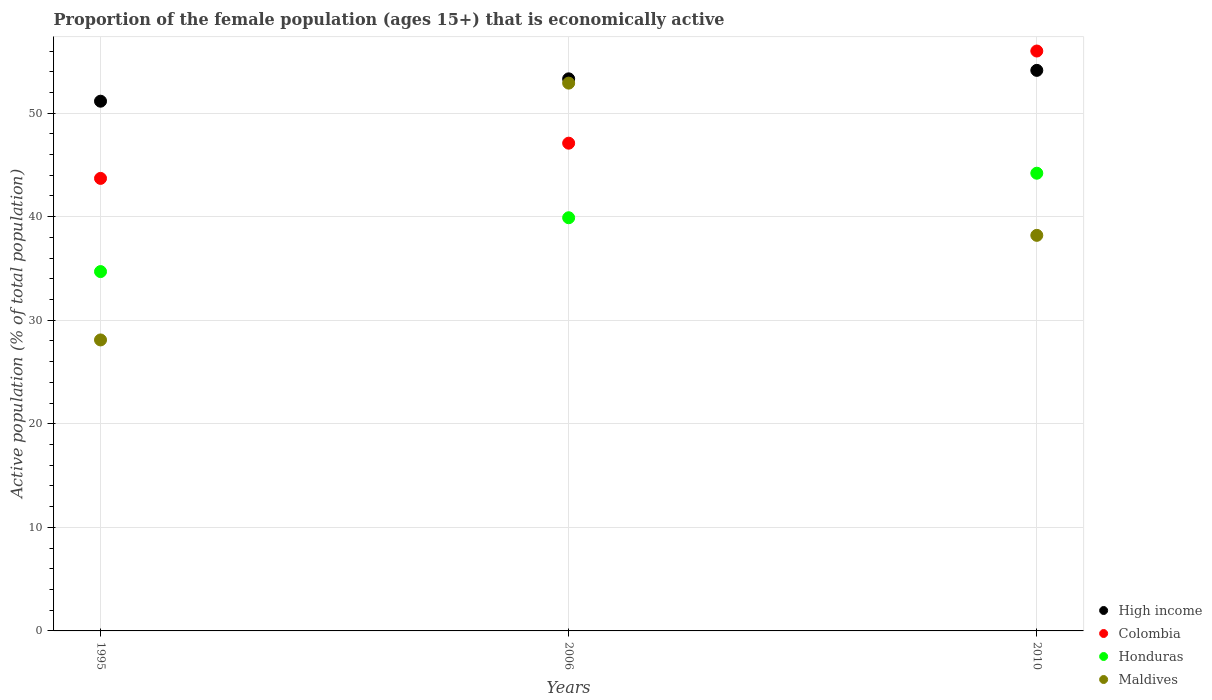What is the proportion of the female population that is economically active in Maldives in 2010?
Make the answer very short. 38.2. Across all years, what is the maximum proportion of the female population that is economically active in Maldives?
Your answer should be very brief. 52.9. Across all years, what is the minimum proportion of the female population that is economically active in High income?
Give a very brief answer. 51.15. In which year was the proportion of the female population that is economically active in Maldives minimum?
Offer a terse response. 1995. What is the total proportion of the female population that is economically active in High income in the graph?
Your answer should be very brief. 158.6. What is the difference between the proportion of the female population that is economically active in Maldives in 2006 and that in 2010?
Offer a terse response. 14.7. What is the difference between the proportion of the female population that is economically active in Colombia in 2006 and the proportion of the female population that is economically active in Maldives in 1995?
Provide a short and direct response. 19. What is the average proportion of the female population that is economically active in High income per year?
Give a very brief answer. 52.87. In the year 2006, what is the difference between the proportion of the female population that is economically active in Colombia and proportion of the female population that is economically active in Maldives?
Your response must be concise. -5.8. What is the ratio of the proportion of the female population that is economically active in Honduras in 2006 to that in 2010?
Ensure brevity in your answer.  0.9. Is the difference between the proportion of the female population that is economically active in Colombia in 1995 and 2006 greater than the difference between the proportion of the female population that is economically active in Maldives in 1995 and 2006?
Your answer should be very brief. Yes. What is the difference between the highest and the second highest proportion of the female population that is economically active in High income?
Your response must be concise. 0.82. What is the difference between the highest and the lowest proportion of the female population that is economically active in Maldives?
Provide a short and direct response. 24.8. Does the proportion of the female population that is economically active in Colombia monotonically increase over the years?
Your answer should be very brief. Yes. Is the proportion of the female population that is economically active in Honduras strictly greater than the proportion of the female population that is economically active in Maldives over the years?
Give a very brief answer. No. How many years are there in the graph?
Keep it short and to the point. 3. Where does the legend appear in the graph?
Your answer should be compact. Bottom right. How many legend labels are there?
Make the answer very short. 4. How are the legend labels stacked?
Keep it short and to the point. Vertical. What is the title of the graph?
Offer a very short reply. Proportion of the female population (ages 15+) that is economically active. Does "Guyana" appear as one of the legend labels in the graph?
Offer a very short reply. No. What is the label or title of the Y-axis?
Your response must be concise. Active population (% of total population). What is the Active population (% of total population) of High income in 1995?
Give a very brief answer. 51.15. What is the Active population (% of total population) in Colombia in 1995?
Make the answer very short. 43.7. What is the Active population (% of total population) of Honduras in 1995?
Provide a succinct answer. 34.7. What is the Active population (% of total population) of Maldives in 1995?
Your response must be concise. 28.1. What is the Active population (% of total population) in High income in 2006?
Ensure brevity in your answer.  53.31. What is the Active population (% of total population) in Colombia in 2006?
Provide a short and direct response. 47.1. What is the Active population (% of total population) in Honduras in 2006?
Offer a terse response. 39.9. What is the Active population (% of total population) in Maldives in 2006?
Your response must be concise. 52.9. What is the Active population (% of total population) of High income in 2010?
Ensure brevity in your answer.  54.13. What is the Active population (% of total population) in Honduras in 2010?
Your answer should be compact. 44.2. What is the Active population (% of total population) in Maldives in 2010?
Give a very brief answer. 38.2. Across all years, what is the maximum Active population (% of total population) in High income?
Offer a very short reply. 54.13. Across all years, what is the maximum Active population (% of total population) of Colombia?
Give a very brief answer. 56. Across all years, what is the maximum Active population (% of total population) in Honduras?
Keep it short and to the point. 44.2. Across all years, what is the maximum Active population (% of total population) of Maldives?
Offer a very short reply. 52.9. Across all years, what is the minimum Active population (% of total population) of High income?
Ensure brevity in your answer.  51.15. Across all years, what is the minimum Active population (% of total population) of Colombia?
Ensure brevity in your answer.  43.7. Across all years, what is the minimum Active population (% of total population) of Honduras?
Keep it short and to the point. 34.7. Across all years, what is the minimum Active population (% of total population) in Maldives?
Provide a succinct answer. 28.1. What is the total Active population (% of total population) in High income in the graph?
Ensure brevity in your answer.  158.6. What is the total Active population (% of total population) in Colombia in the graph?
Offer a terse response. 146.8. What is the total Active population (% of total population) in Honduras in the graph?
Your response must be concise. 118.8. What is the total Active population (% of total population) of Maldives in the graph?
Provide a short and direct response. 119.2. What is the difference between the Active population (% of total population) of High income in 1995 and that in 2006?
Your answer should be very brief. -2.16. What is the difference between the Active population (% of total population) in Colombia in 1995 and that in 2006?
Keep it short and to the point. -3.4. What is the difference between the Active population (% of total population) in Maldives in 1995 and that in 2006?
Make the answer very short. -24.8. What is the difference between the Active population (% of total population) in High income in 1995 and that in 2010?
Your answer should be compact. -2.98. What is the difference between the Active population (% of total population) in Colombia in 1995 and that in 2010?
Keep it short and to the point. -12.3. What is the difference between the Active population (% of total population) of Honduras in 1995 and that in 2010?
Offer a terse response. -9.5. What is the difference between the Active population (% of total population) in Maldives in 1995 and that in 2010?
Give a very brief answer. -10.1. What is the difference between the Active population (% of total population) of High income in 2006 and that in 2010?
Your answer should be compact. -0.82. What is the difference between the Active population (% of total population) in High income in 1995 and the Active population (% of total population) in Colombia in 2006?
Your response must be concise. 4.05. What is the difference between the Active population (% of total population) in High income in 1995 and the Active population (% of total population) in Honduras in 2006?
Your answer should be compact. 11.25. What is the difference between the Active population (% of total population) of High income in 1995 and the Active population (% of total population) of Maldives in 2006?
Ensure brevity in your answer.  -1.75. What is the difference between the Active population (% of total population) in Colombia in 1995 and the Active population (% of total population) in Maldives in 2006?
Offer a terse response. -9.2. What is the difference between the Active population (% of total population) in Honduras in 1995 and the Active population (% of total population) in Maldives in 2006?
Provide a short and direct response. -18.2. What is the difference between the Active population (% of total population) of High income in 1995 and the Active population (% of total population) of Colombia in 2010?
Your response must be concise. -4.85. What is the difference between the Active population (% of total population) of High income in 1995 and the Active population (% of total population) of Honduras in 2010?
Your response must be concise. 6.95. What is the difference between the Active population (% of total population) of High income in 1995 and the Active population (% of total population) of Maldives in 2010?
Offer a terse response. 12.95. What is the difference between the Active population (% of total population) of High income in 2006 and the Active population (% of total population) of Colombia in 2010?
Your answer should be very brief. -2.69. What is the difference between the Active population (% of total population) in High income in 2006 and the Active population (% of total population) in Honduras in 2010?
Give a very brief answer. 9.11. What is the difference between the Active population (% of total population) of High income in 2006 and the Active population (% of total population) of Maldives in 2010?
Your answer should be very brief. 15.11. What is the difference between the Active population (% of total population) in Colombia in 2006 and the Active population (% of total population) in Maldives in 2010?
Offer a terse response. 8.9. What is the difference between the Active population (% of total population) in Honduras in 2006 and the Active population (% of total population) in Maldives in 2010?
Keep it short and to the point. 1.7. What is the average Active population (% of total population) of High income per year?
Provide a short and direct response. 52.87. What is the average Active population (% of total population) of Colombia per year?
Your answer should be compact. 48.93. What is the average Active population (% of total population) of Honduras per year?
Offer a very short reply. 39.6. What is the average Active population (% of total population) in Maldives per year?
Your answer should be compact. 39.73. In the year 1995, what is the difference between the Active population (% of total population) in High income and Active population (% of total population) in Colombia?
Your answer should be compact. 7.45. In the year 1995, what is the difference between the Active population (% of total population) of High income and Active population (% of total population) of Honduras?
Offer a very short reply. 16.45. In the year 1995, what is the difference between the Active population (% of total population) of High income and Active population (% of total population) of Maldives?
Offer a very short reply. 23.05. In the year 1995, what is the difference between the Active population (% of total population) of Colombia and Active population (% of total population) of Maldives?
Give a very brief answer. 15.6. In the year 1995, what is the difference between the Active population (% of total population) in Honduras and Active population (% of total population) in Maldives?
Your answer should be compact. 6.6. In the year 2006, what is the difference between the Active population (% of total population) in High income and Active population (% of total population) in Colombia?
Offer a very short reply. 6.21. In the year 2006, what is the difference between the Active population (% of total population) of High income and Active population (% of total population) of Honduras?
Ensure brevity in your answer.  13.41. In the year 2006, what is the difference between the Active population (% of total population) of High income and Active population (% of total population) of Maldives?
Provide a short and direct response. 0.41. In the year 2006, what is the difference between the Active population (% of total population) in Colombia and Active population (% of total population) in Maldives?
Offer a very short reply. -5.8. In the year 2006, what is the difference between the Active population (% of total population) in Honduras and Active population (% of total population) in Maldives?
Offer a very short reply. -13. In the year 2010, what is the difference between the Active population (% of total population) in High income and Active population (% of total population) in Colombia?
Ensure brevity in your answer.  -1.87. In the year 2010, what is the difference between the Active population (% of total population) in High income and Active population (% of total population) in Honduras?
Offer a very short reply. 9.93. In the year 2010, what is the difference between the Active population (% of total population) in High income and Active population (% of total population) in Maldives?
Ensure brevity in your answer.  15.93. In the year 2010, what is the difference between the Active population (% of total population) in Honduras and Active population (% of total population) in Maldives?
Keep it short and to the point. 6. What is the ratio of the Active population (% of total population) of High income in 1995 to that in 2006?
Make the answer very short. 0.96. What is the ratio of the Active population (% of total population) in Colombia in 1995 to that in 2006?
Provide a short and direct response. 0.93. What is the ratio of the Active population (% of total population) in Honduras in 1995 to that in 2006?
Your answer should be very brief. 0.87. What is the ratio of the Active population (% of total population) in Maldives in 1995 to that in 2006?
Offer a very short reply. 0.53. What is the ratio of the Active population (% of total population) in High income in 1995 to that in 2010?
Your answer should be compact. 0.94. What is the ratio of the Active population (% of total population) of Colombia in 1995 to that in 2010?
Offer a terse response. 0.78. What is the ratio of the Active population (% of total population) in Honduras in 1995 to that in 2010?
Provide a succinct answer. 0.79. What is the ratio of the Active population (% of total population) in Maldives in 1995 to that in 2010?
Provide a short and direct response. 0.74. What is the ratio of the Active population (% of total population) of High income in 2006 to that in 2010?
Make the answer very short. 0.98. What is the ratio of the Active population (% of total population) in Colombia in 2006 to that in 2010?
Ensure brevity in your answer.  0.84. What is the ratio of the Active population (% of total population) in Honduras in 2006 to that in 2010?
Offer a terse response. 0.9. What is the ratio of the Active population (% of total population) of Maldives in 2006 to that in 2010?
Your answer should be very brief. 1.38. What is the difference between the highest and the second highest Active population (% of total population) in High income?
Give a very brief answer. 0.82. What is the difference between the highest and the second highest Active population (% of total population) of Honduras?
Make the answer very short. 4.3. What is the difference between the highest and the lowest Active population (% of total population) of High income?
Keep it short and to the point. 2.98. What is the difference between the highest and the lowest Active population (% of total population) in Colombia?
Provide a succinct answer. 12.3. What is the difference between the highest and the lowest Active population (% of total population) in Honduras?
Provide a short and direct response. 9.5. What is the difference between the highest and the lowest Active population (% of total population) in Maldives?
Ensure brevity in your answer.  24.8. 